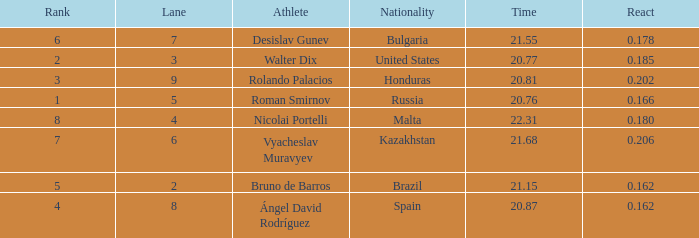What's Bulgaria's lane with a time more than 21.55? None. 